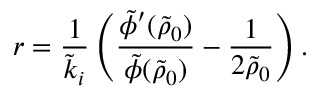<formula> <loc_0><loc_0><loc_500><loc_500>r = \frac { 1 } { \tilde { k } _ { i } } \left ( \frac { \tilde { \phi } ^ { \prime } ( \tilde { \rho } _ { 0 } ) } { \tilde { \phi } ( \tilde { \rho } _ { 0 } ) } - \frac { 1 } { 2 \tilde { \rho } _ { 0 } } \right ) .</formula> 